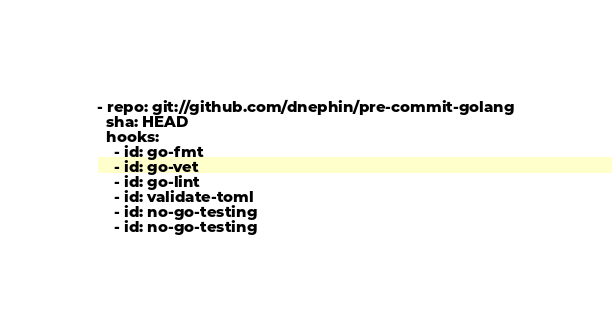<code> <loc_0><loc_0><loc_500><loc_500><_YAML_>- repo: git://github.com/dnephin/pre-commit-golang
  sha: HEAD
  hooks:
    - id: go-fmt
    - id: go-vet
    - id: go-lint
    - id: validate-toml
    - id: no-go-testing
    - id: no-go-testing
</code> 